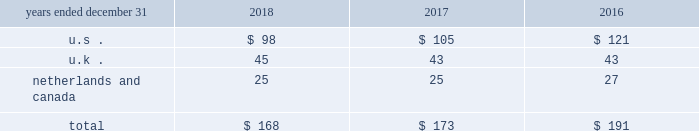( 3 ) refer to note 2 201csummary of significant accounting principles and practices 201d for further information .
13 .
Employee benefitsp y defined contribution savings plans aon maintains defined contribution savings plans for the benefit of its employees .
The expense recognized for these plans is included in compensation and benefits in the consolidated statements of income .
The expense for the significant plans in the u.s. , u.k. , netherlands and canada is as follows ( in millions ) : .
Pension and other postretirement benefits the company sponsors defined benefit pension and postretirement health and welfare plans that provide retirement , medical , and life insurance benefits .
The postretirement health care plans are contributory , with retiree contributions adjusted annually , and the aa life insurance and pension plans are generally noncontributory .
The significant u.s. , u.k. , netherlands and canadian pension plans are closed to new entrants. .
In 2018 what was the percent of the expenses in the us to the total benefit expense? 
Computations: (98 / 168)
Answer: 0.58333. 